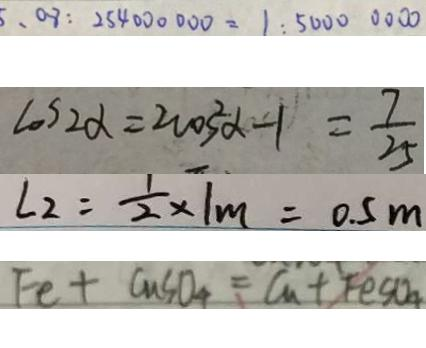<formula> <loc_0><loc_0><loc_500><loc_500>、 0 8 : 2 5 4 0 0 0 0 0 0 = 1 : 5 0 0 0 0 0 0 0 
 \cos 2 \alpha = 2 \cos ^ { 2 } \alpha - 1 = \frac { 7 } { 2 5 } 
 L _ { 2 } = \frac { 1 } { 2 } \times 1 m = 0 . 5 m 
 F e + C u S O _ { 4 } = C _ { 1 } + F e S O _ { 4 }</formula> 